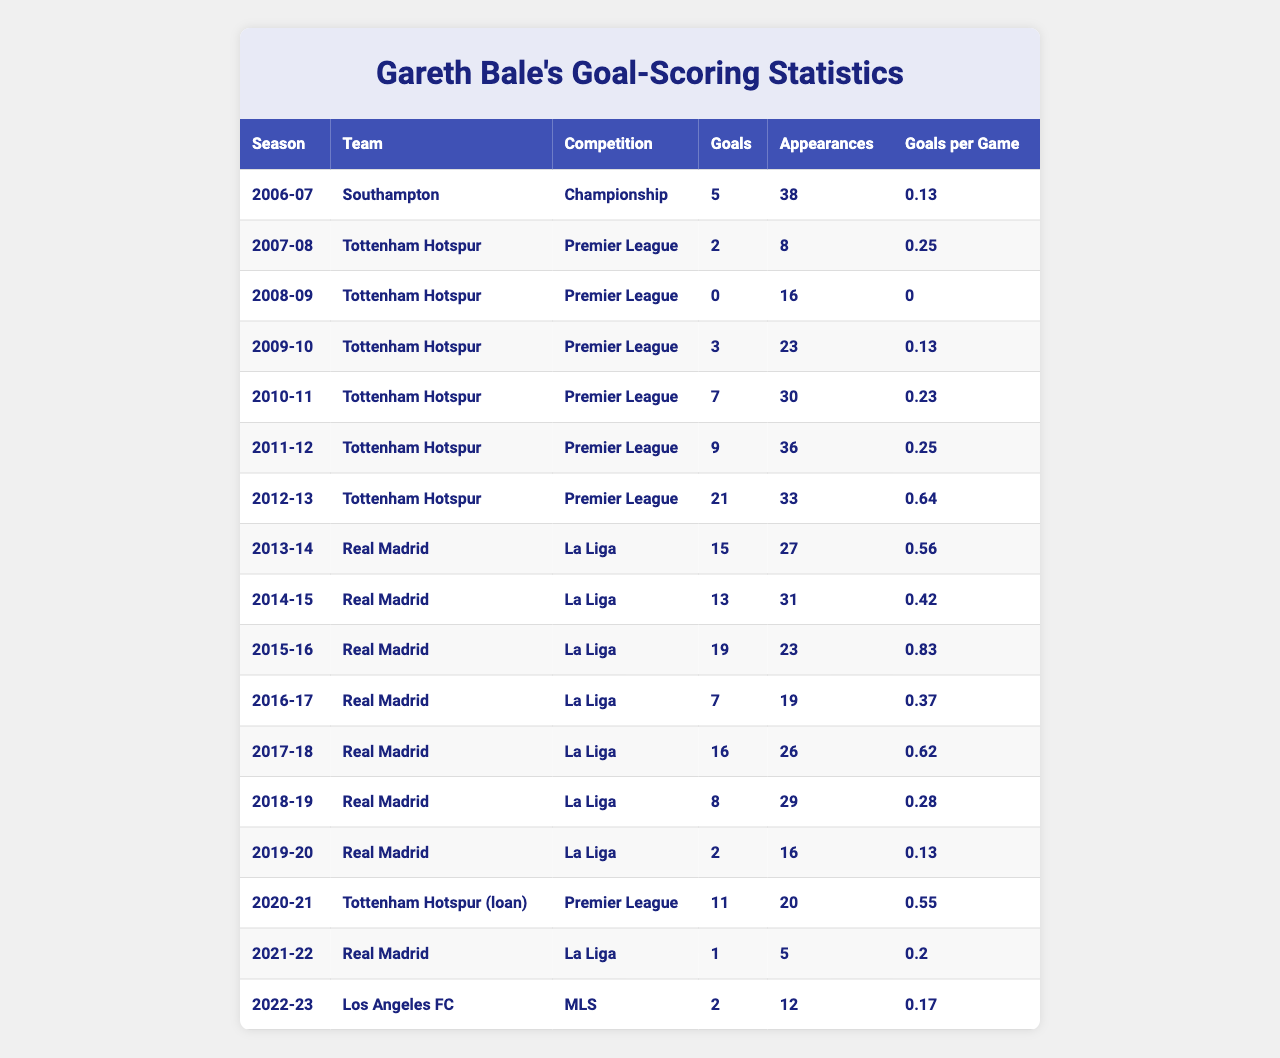What was Gareth Bale's highest goal tally in a single season? Looking at the table, we see that the highest number of goals Bale scored in a single season is 21 during the 2012-13 season with Tottenham Hotspur.
Answer: 21 During which season did Bale score the most goals while playing for Real Madrid? In the table, we can see that Bale scored the most goals for Real Madrid in the 2015-16 season, with a total of 19 goals.
Answer: 19 How many goals did Gareth Bale score in the 2022-23 season? According to the table, in the 2022-23 season, Bale scored 2 goals while playing for Los Angeles FC.
Answer: 2 What was Bale's goal-scoring rate (goals per game) during his loan to Tottenham Hotspur in the 2020-21 season? From the table, he scored 11 goals in 20 appearances, giving him a goals per game rate of 0.55 during that season.
Answer: 0.55 Which competition did Gareth Bale score the most goals in? By analyzing the total goals across competitions, we find that in the Premier League, Bale scored a total of 61 goals, which is more than in La Liga (69) or MLS (2), making it the highest overall.
Answer: Premier League In which season did Bale have the lowest goals per game ratio? Referring to the table, the lowest goals per game ratio is 0 during the 2008-09 season when he did not score any goals despite 16 appearances.
Answer: 0 How many total goals did Gareth Bale score throughout his career according to the table? Summing up all the goals from each season in the table, we find that he scored a total of 69 goals throughout his career.
Answer: 69 Was Gareth Bale more prolific in the Premier League or La Liga based on goals per game? By calculating the goals per game for both leagues, Bale had an average of 0.45 in the Premier League and 0.44 in La Liga, indicating he was slightly more prolific in the Premier League.
Answer: Premier League What is the average number of goals scored by Bale per season? To find the average, we total the 69 goals scored across 17 seasons: 69/17 = approximately 4.06.
Answer: 4.06 Did Gareth Bale ever score more than 15 goals in a single season for Real Madrid? Yes, he scored 19 goals in the 2015-16 season, which is more than 15.
Answer: Yes 